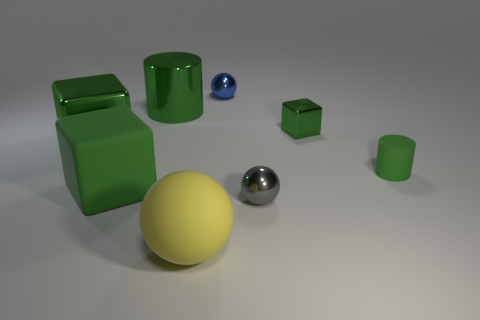Subtract all matte balls. How many balls are left? 2 Add 1 small blue objects. How many objects exist? 9 Subtract all gray balls. How many balls are left? 2 Subtract all cubes. How many objects are left? 5 Subtract all tiny cylinders. Subtract all large purple objects. How many objects are left? 7 Add 5 cubes. How many cubes are left? 8 Add 1 metal cubes. How many metal cubes exist? 3 Subtract 0 red blocks. How many objects are left? 8 Subtract 2 spheres. How many spheres are left? 1 Subtract all blue cylinders. Subtract all cyan blocks. How many cylinders are left? 2 